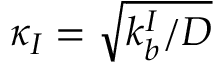Convert formula to latex. <formula><loc_0><loc_0><loc_500><loc_500>\kappa _ { I } = \sqrt { k _ { b } ^ { I } / D }</formula> 